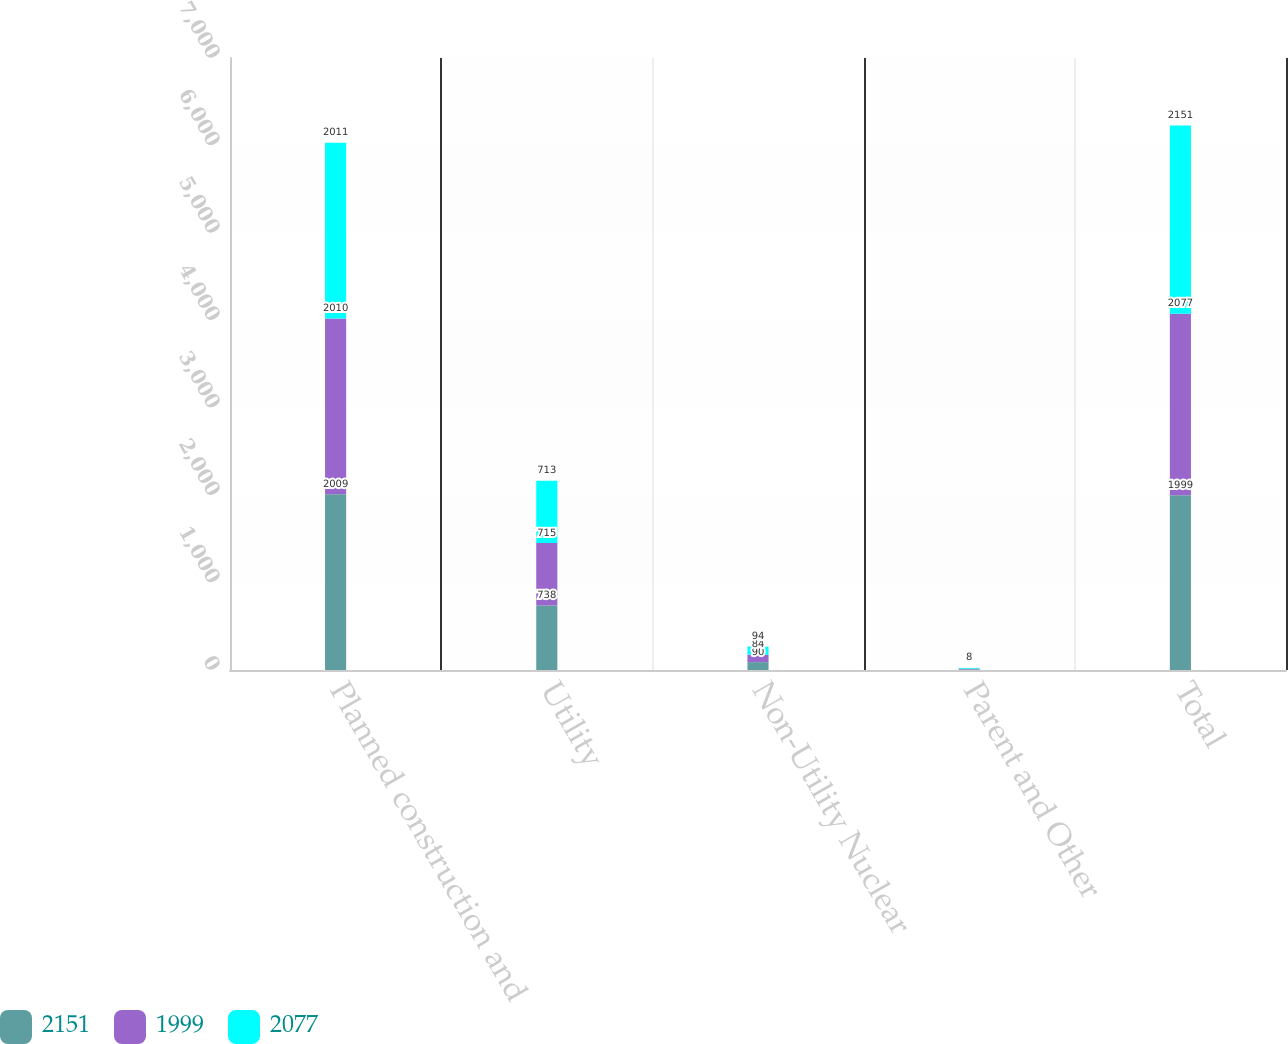<chart> <loc_0><loc_0><loc_500><loc_500><stacked_bar_chart><ecel><fcel>Planned construction and<fcel>Utility<fcel>Non-Utility Nuclear<fcel>Parent and Other<fcel>Total<nl><fcel>2151<fcel>2009<fcel>738<fcel>90<fcel>8<fcel>1999<nl><fcel>1999<fcel>2010<fcel>715<fcel>84<fcel>8<fcel>2077<nl><fcel>2077<fcel>2011<fcel>713<fcel>94<fcel>8<fcel>2151<nl></chart> 